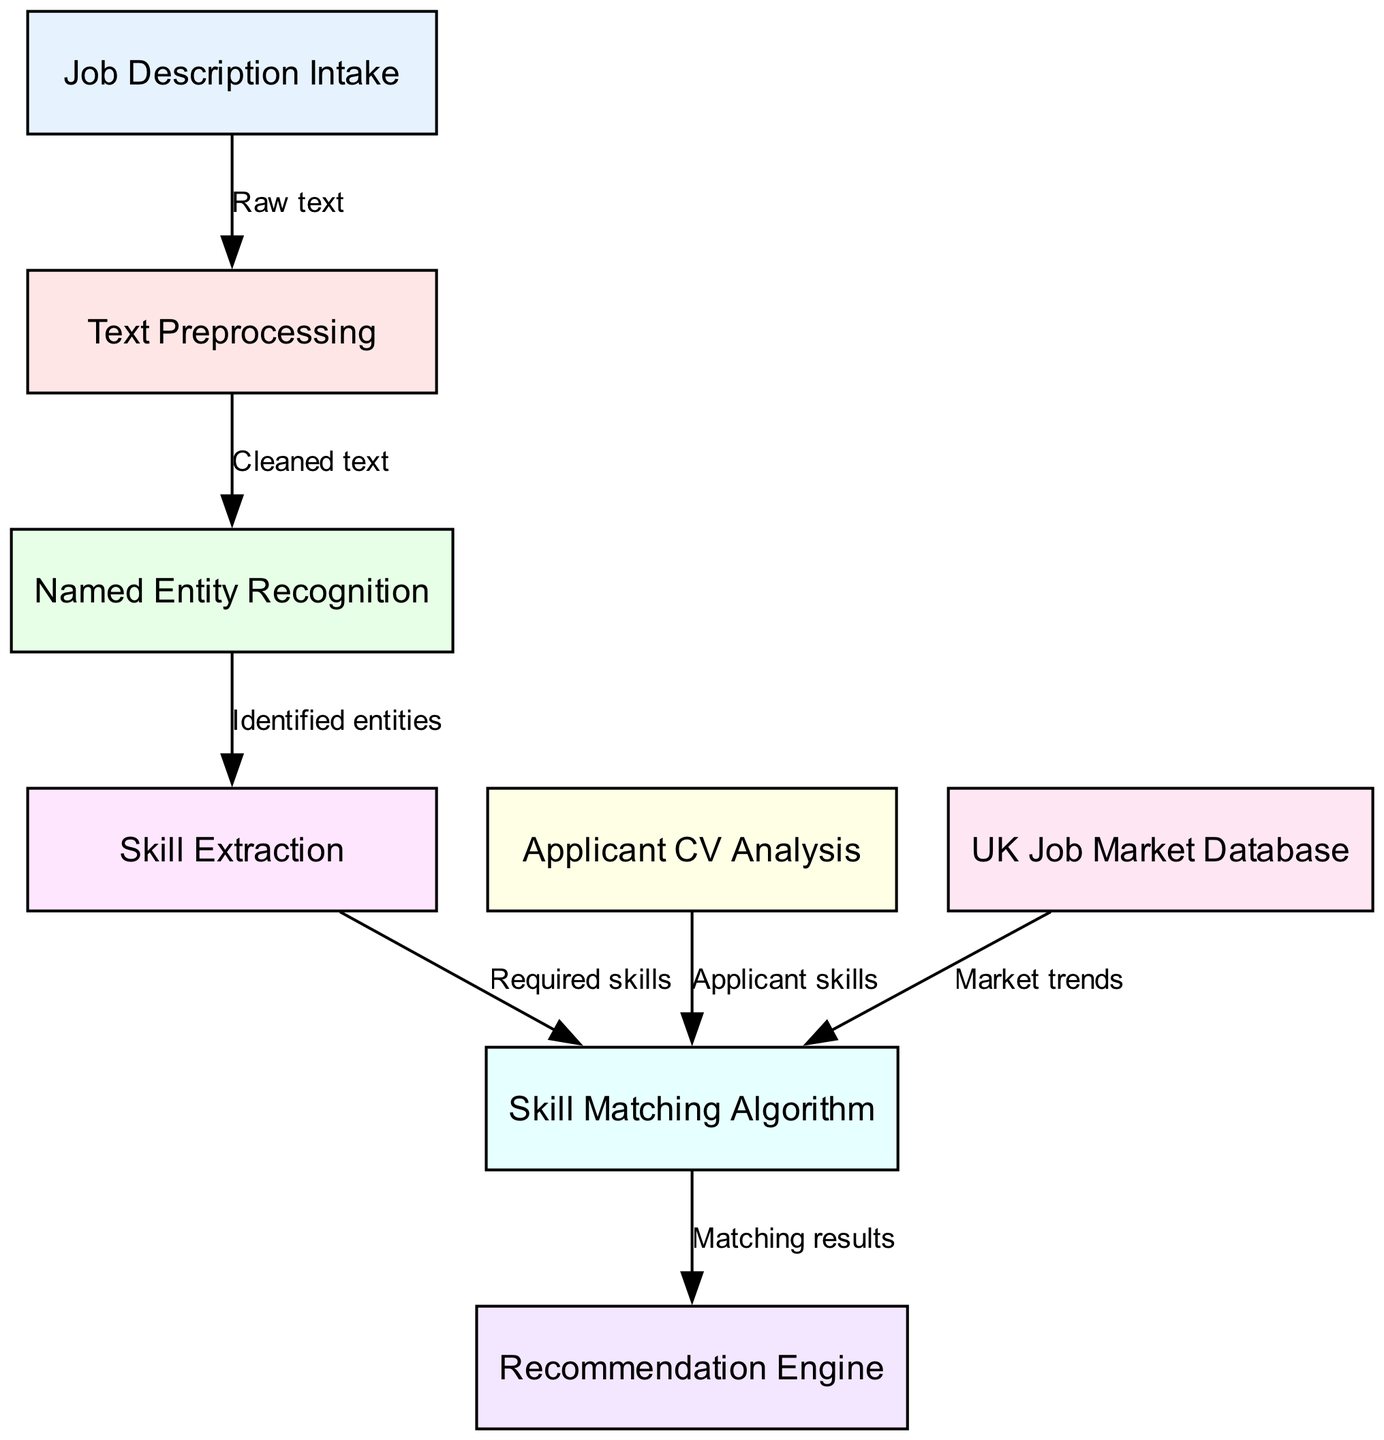What is the first step in the diagram? The first step in the diagram is labeled "Job Description Intake", which indicates the initial process where job descriptions are collected for analysis.
Answer: Job Description Intake How many nodes are in the diagram? By counting the unique identifiers for each node in the diagram, we find there are 8 nodes.
Answer: 8 What connects "Named Entity Recognition" to "Skill Extraction"? The connection between "Named Entity Recognition" and "Skill Extraction" is labeled "Identified entities", indicating that the entities identified in the previous step are used to extract relevant skills.
Answer: Identified entities Which nodes feed into the "Skill Matching Algorithm"? The nodes that feed into the "Skill Matching Algorithm" are "Skill Extraction", "Applicant CV Analysis", and "UK Job Market Database", all contributing their outputs for matching purposes.
Answer: Skill Extraction, Applicant CV Analysis, UK Job Market Database What is the output from the "Skill Matching Algorithm"? The output from the "Skill Matching Algorithm" is labeled as "Matching results", signifying the final results of the skills match process.
Answer: Matching results What does the "Applicant CV Analysis" node provide? The "Applicant CV Analysis" node provides "Applicant skills", which are the skills extracted from applicants' CVs to be matched against job requirements.
Answer: Applicant skills What is the last step in the diagram? The last step in the diagram is the "Recommendation Engine", which likely recommends suitable job matches based on the previous analyses.
Answer: Recommendation Engine Which node directly follows "Text Preprocessing"? The node that directly follows "Text Preprocessing" is "Named Entity Recognition", as indicated by the connection showing the flow of cleaned text into the next processing stage.
Answer: Named Entity Recognition What type of data does the "UK Job Market Database" provide to the algorithm? The "UK Job Market Database" provides "Market trends", which are important in informing the skill matching process with up-to-date job market information.
Answer: Market trends 